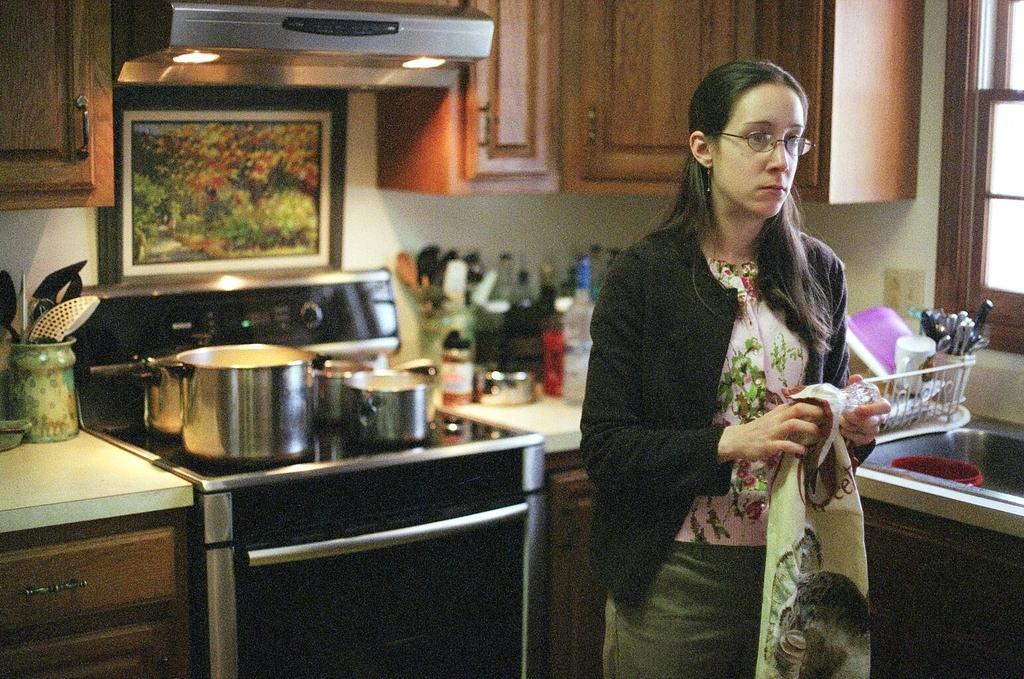In one or two sentences, can you explain what this image depicts? On the right side of the image we can see woman standing and holding a cloth. In the background we can see stove, vessels, countertop, cupboards, chimney, lights, dishwasher, bottles, spoons, knife, window and wall. 